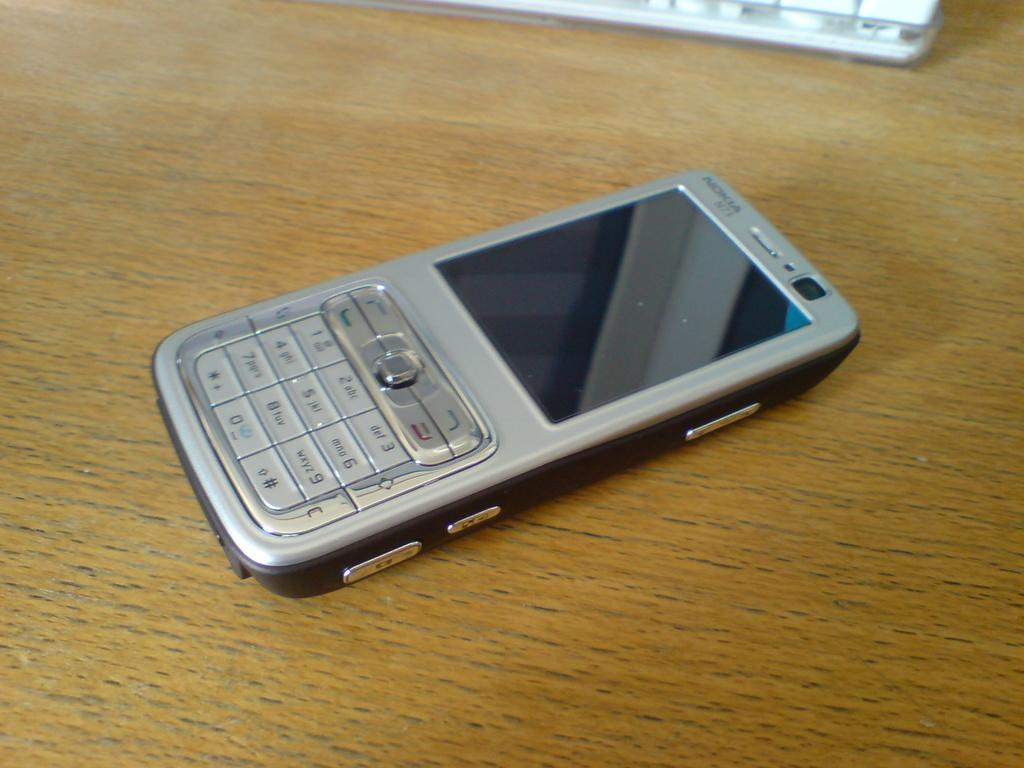<image>
Summarize the visual content of the image. A Nokia cell phone sits on a wood table 